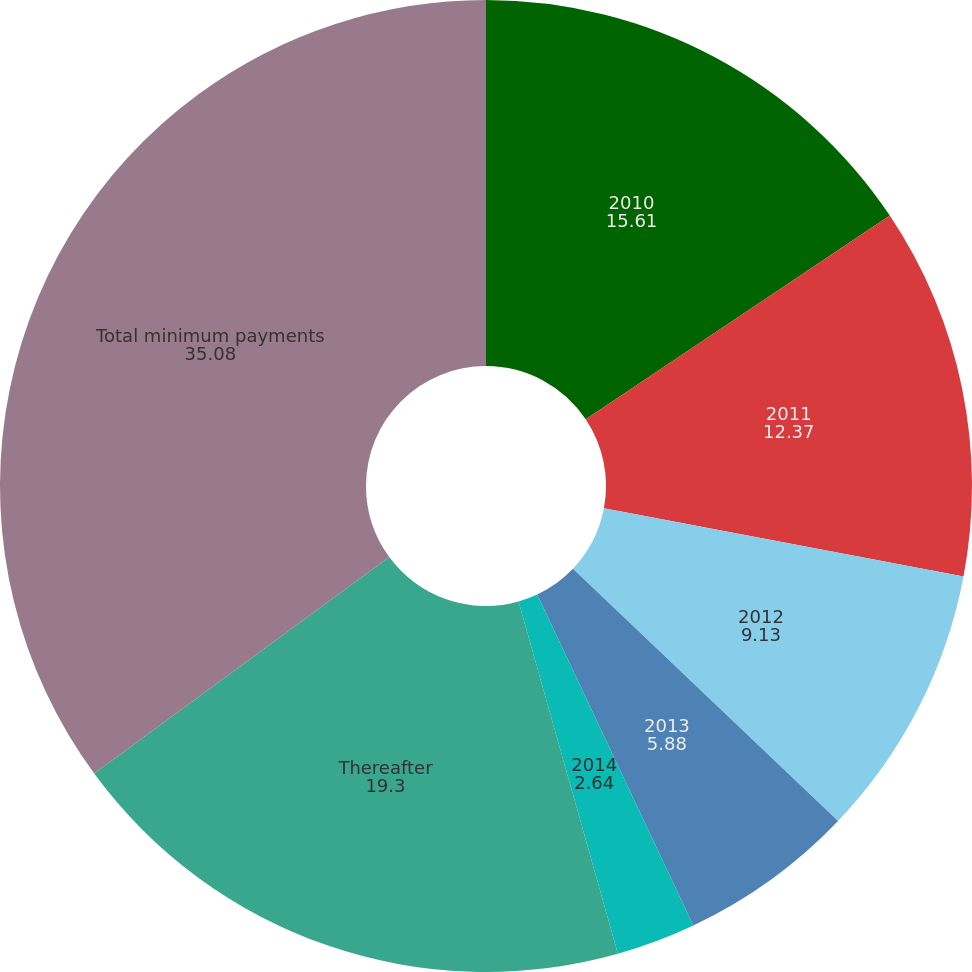Convert chart to OTSL. <chart><loc_0><loc_0><loc_500><loc_500><pie_chart><fcel>2010<fcel>2011<fcel>2012<fcel>2013<fcel>2014<fcel>Thereafter<fcel>Total minimum payments<nl><fcel>15.61%<fcel>12.37%<fcel>9.13%<fcel>5.88%<fcel>2.64%<fcel>19.3%<fcel>35.08%<nl></chart> 